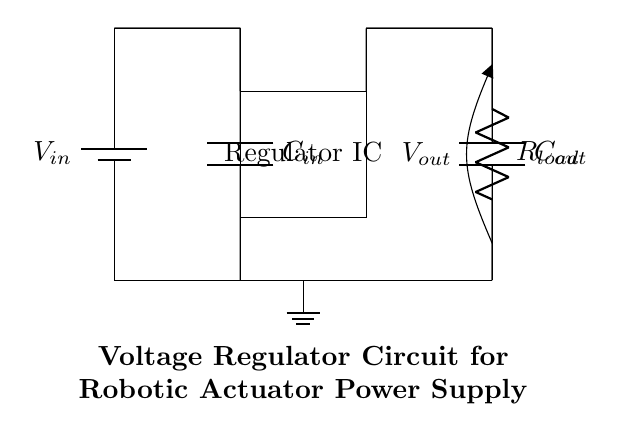What does the input capacitor do in this circuit? The input capacitor, labeled C in, is used to filter and stabilize the input voltage coming from the battery. It helps to smooth out any fluctuations or noise in the input voltage before it reaches the voltage regulator, ensuring a more stable supply for the regulator to work properly.
Answer: filters and stabilizes input voltage What is the role of the voltage regulator IC? The voltage regulator IC regulates the output voltage to a specific, stable value regardless of variations in the input voltage or load conditions. It ensures that the output voltage remains constant, providing reliable power to robotic actuators, which is critical for their performance.
Answer: regulates output voltage What is the voltage at the output labeled in the circuit? The output voltage is represented as V out in the circuit. It indicates the voltage that is supplied to the load connected at the output of the circuit. In this context, V out is the regulated voltage intended for the robotic actuators.
Answer: V out What is the purpose of the output capacitor? The output capacitor, labeled C out, is used to smooth the output voltage from the voltage regulator by filtering out any high-frequency noise. This ensures that the output signal is stable and clean, minimizing potential ripple effects that could affect the performance of the connected robotic actuators.
Answer: smooths output voltage How does the load resistor affect the circuit? The load resistor, labeled R load, represents the actual load that the voltage regulator is powering. Its resistance value will determine how much current is drawn from the circuit, which in turn can affect the performance and stability of the voltage regulator output based on the design specifications.
Answer: affects current draw 